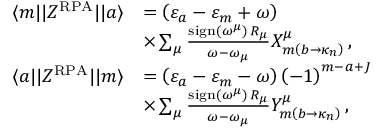<formula> <loc_0><loc_0><loc_500><loc_500>\begin{array} { r l } { \langle m | | Z ^ { R P A } | | a \rangle } & { = \left ( \varepsilon _ { a } - \varepsilon _ { m } + \omega \right ) } \\ & { \times \sum _ { \mu } \frac { s i g n \left ( \omega ^ { \mu } \right ) \, R _ { \mu } } { \omega - \omega _ { \mu } } X _ { m \left ( b \rightarrow \kappa _ { n } \right ) } ^ { \mu } \, , } \\ { \langle a | | Z ^ { R P A } | | m \rangle } & { = \left ( \varepsilon _ { a } - \varepsilon _ { m } - \omega \right ) \left ( - 1 \right ) ^ { m - a + J } } \\ & { \times \sum _ { \mu } \frac { s i g n \left ( \omega ^ { \mu } \right ) \, R _ { \mu } } { \omega - \omega _ { \mu } } Y _ { m \left ( b \rightarrow \kappa _ { n } \right ) } ^ { \mu } \, , } \end{array}</formula> 